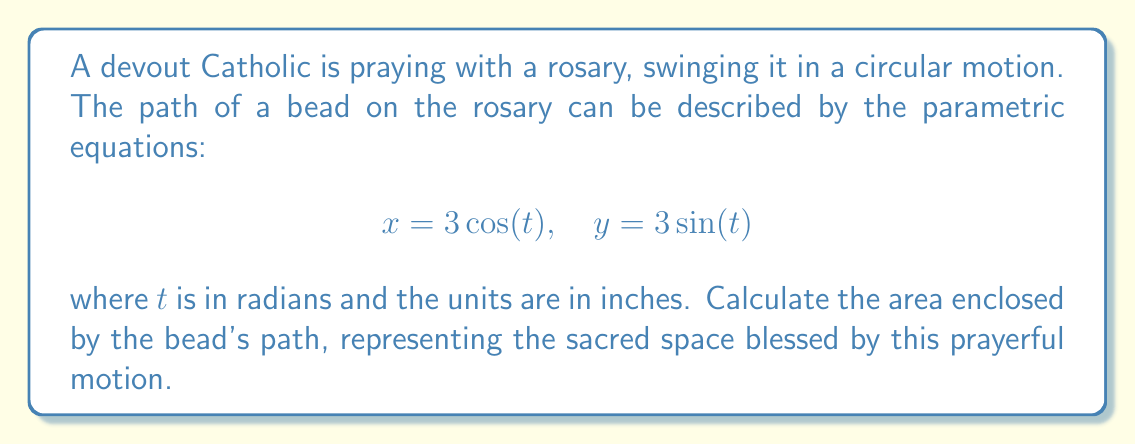Teach me how to tackle this problem. To find the area enclosed by the bead's path, we need to follow these steps:

1) First, we recognize that the parametric equations describe a circle. The general form of parametric equations for a circle is:

   $$x = r\cos(t), \quad y = r\sin(t)$$

   where $r$ is the radius of the circle.

2) In our case, $r = 3$ inches.

3) The area of a circle is given by the formula $A = \pi r^2$.

4) Substituting our radius:

   $$A = \pi (3)^2 = 9\pi$$

5) Therefore, the area enclosed by the bead's path is $9\pi$ square inches.

This circular motion of the rosary bead creates a sacred space, symbolizing the completeness and perfection of God's love. The area within this circle represents the spiritual realm blessed by the prayer, encompassing the faithful in divine protection.
Answer: $9\pi$ square inches 